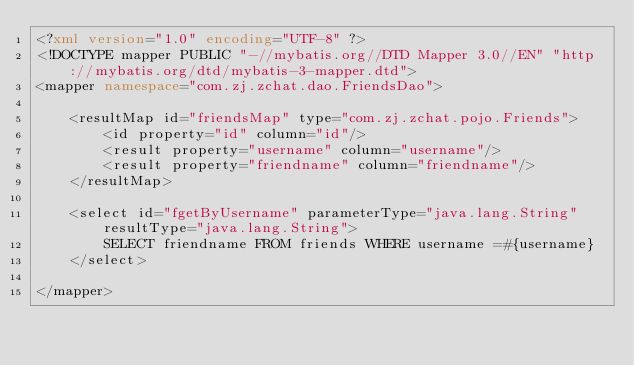Convert code to text. <code><loc_0><loc_0><loc_500><loc_500><_XML_><?xml version="1.0" encoding="UTF-8" ?>
<!DOCTYPE mapper PUBLIC "-//mybatis.org//DTD Mapper 3.0//EN" "http://mybatis.org/dtd/mybatis-3-mapper.dtd">
<mapper namespace="com.zj.zchat.dao.FriendsDao">

    <resultMap id="friendsMap" type="com.zj.zchat.pojo.Friends">
        <id property="id" column="id"/>
        <result property="username" column="username"/>
        <result property="friendname" column="friendname"/>
    </resultMap>

    <select id="fgetByUsername" parameterType="java.lang.String" resultType="java.lang.String">
        SELECT friendname FROM friends WHERE username =#{username}
    </select>

</mapper></code> 